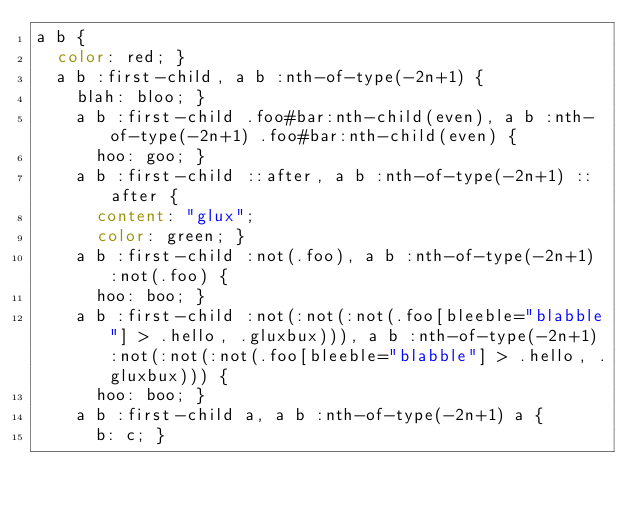Convert code to text. <code><loc_0><loc_0><loc_500><loc_500><_CSS_>a b {
  color: red; }
  a b :first-child, a b :nth-of-type(-2n+1) {
    blah: bloo; }
    a b :first-child .foo#bar:nth-child(even), a b :nth-of-type(-2n+1) .foo#bar:nth-child(even) {
      hoo: goo; }
    a b :first-child ::after, a b :nth-of-type(-2n+1) ::after {
      content: "glux";
      color: green; }
    a b :first-child :not(.foo), a b :nth-of-type(-2n+1) :not(.foo) {
      hoo: boo; }
    a b :first-child :not(:not(:not(.foo[bleeble="blabble"] > .hello, .gluxbux))), a b :nth-of-type(-2n+1) :not(:not(:not(.foo[bleeble="blabble"] > .hello, .gluxbux))) {
      hoo: boo; }
    a b :first-child a, a b :nth-of-type(-2n+1) a {
      b: c; }
</code> 